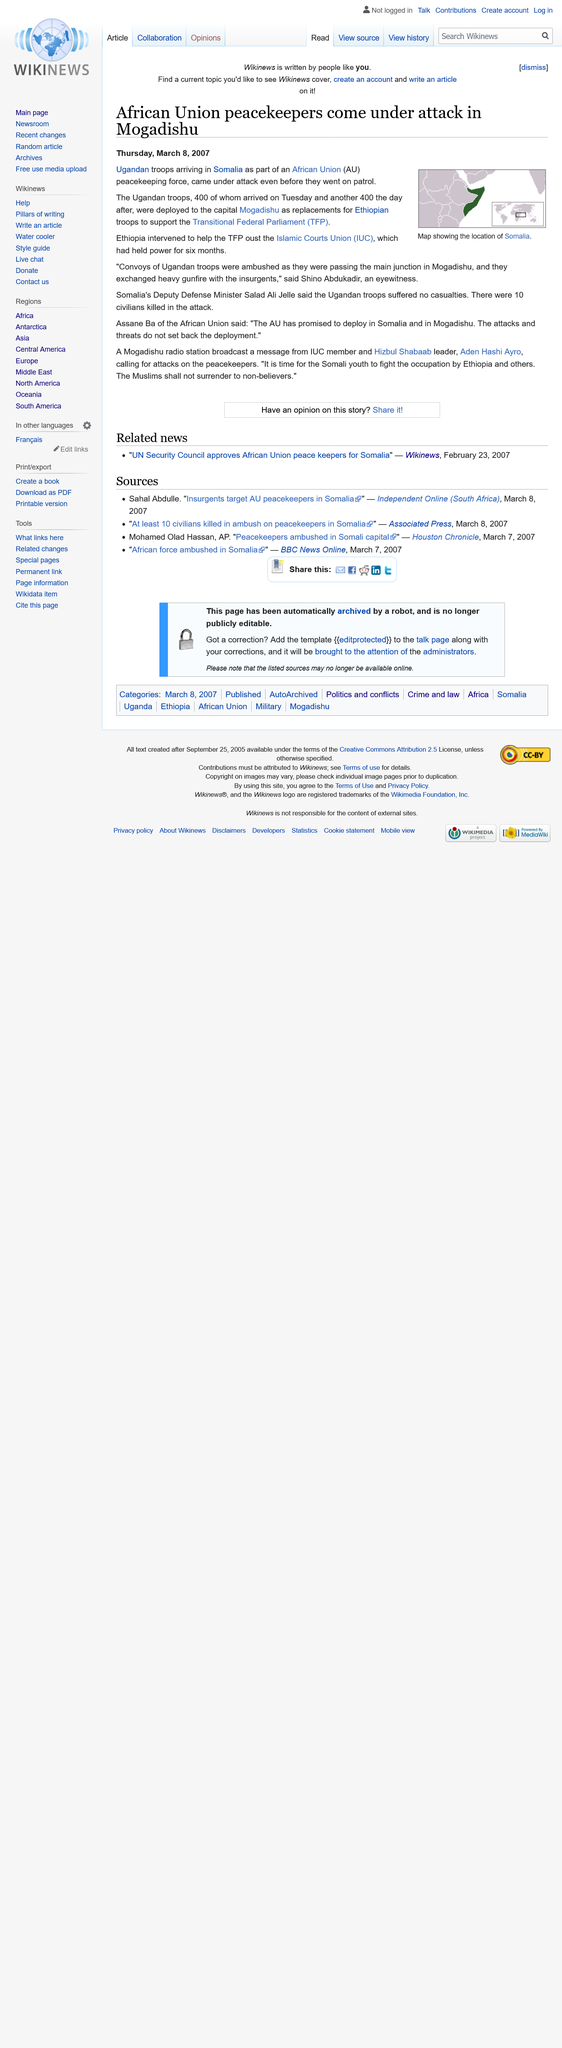Indicate a few pertinent items in this graphic. Ugandan troops replaced Ethiopian troops in Somalia, and they were replaced by troops of a particular nationality. The Ugandan troops were deployed to Somalia and were stationed in the city of Mogadishu, the capital of Somalia. In the attack on the African Union peacekeeping force, 10 civilians were tragically killed. 